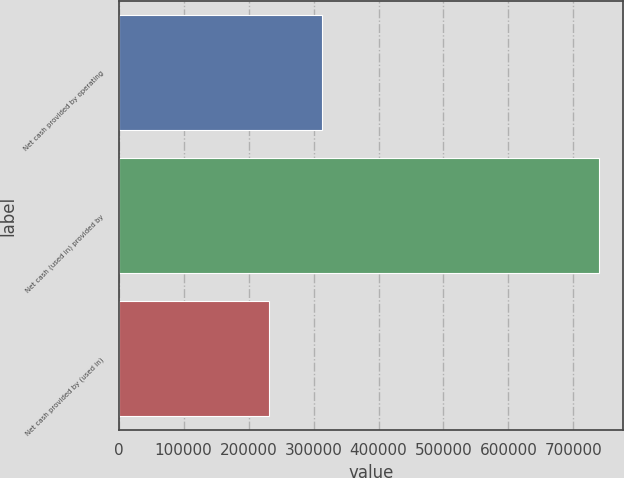Convert chart. <chart><loc_0><loc_0><loc_500><loc_500><bar_chart><fcel>Net cash provided by operating<fcel>Net cash (used in) provided by<fcel>Net cash provided by (used in)<nl><fcel>312860<fcel>739597<fcel>232099<nl></chart> 